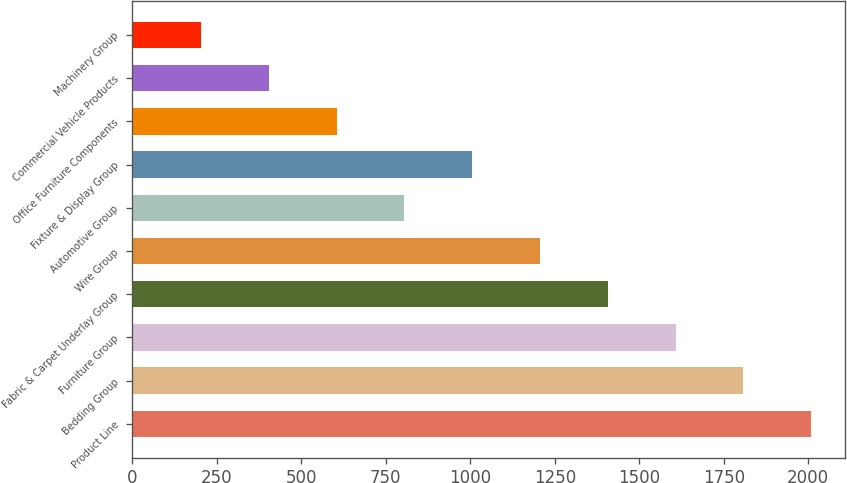Convert chart. <chart><loc_0><loc_0><loc_500><loc_500><bar_chart><fcel>Product Line<fcel>Bedding Group<fcel>Furniture Group<fcel>Fabric & Carpet Underlay Group<fcel>Wire Group<fcel>Automotive Group<fcel>Fixture & Display Group<fcel>Office Furniture Components<fcel>Commercial Vehicle Products<fcel>Machinery Group<nl><fcel>2009<fcel>1808.3<fcel>1607.6<fcel>1406.9<fcel>1206.2<fcel>804.8<fcel>1005.5<fcel>604.1<fcel>403.4<fcel>202.7<nl></chart> 